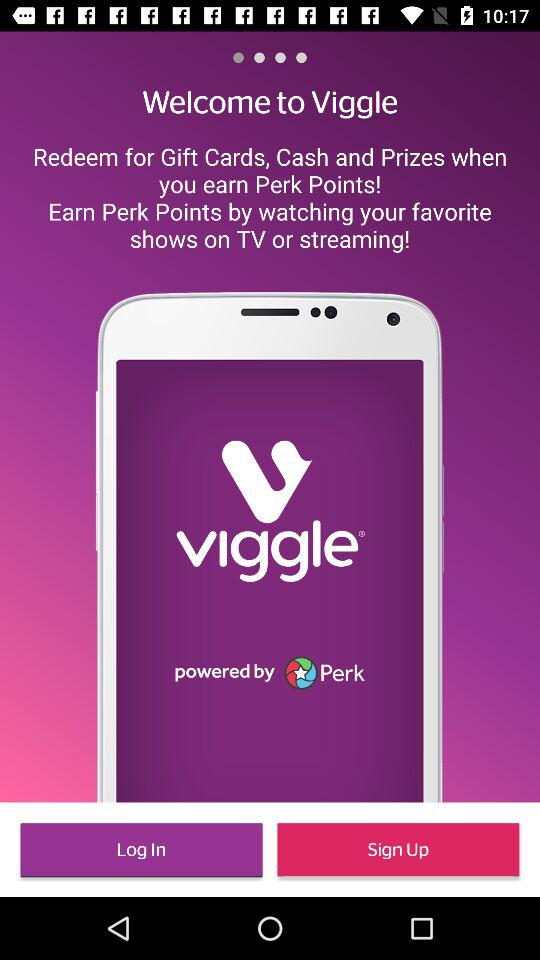How can users earn perk points? Users can earn perk points by watching their favorite shows on TV or streaming. 